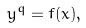Convert formula to latex. <formula><loc_0><loc_0><loc_500><loc_500>y ^ { q } = f ( x ) ,</formula> 